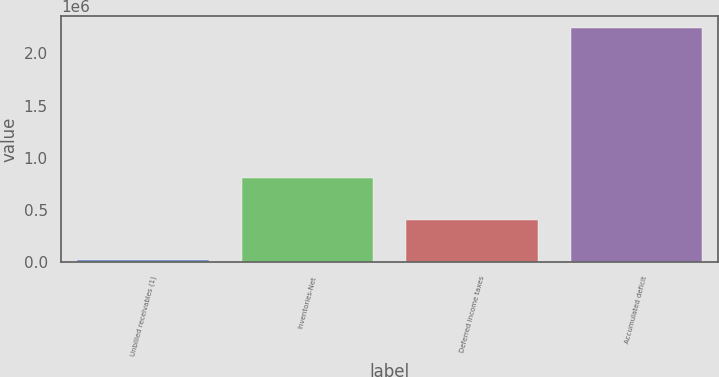<chart> <loc_0><loc_0><loc_500><loc_500><bar_chart><fcel>Unbilled receivables (1)<fcel>Inventories-Net<fcel>Deferred income taxes<fcel>Accumulated deficit<nl><fcel>18328<fcel>801315<fcel>400507<fcel>2.24329e+06<nl></chart> 